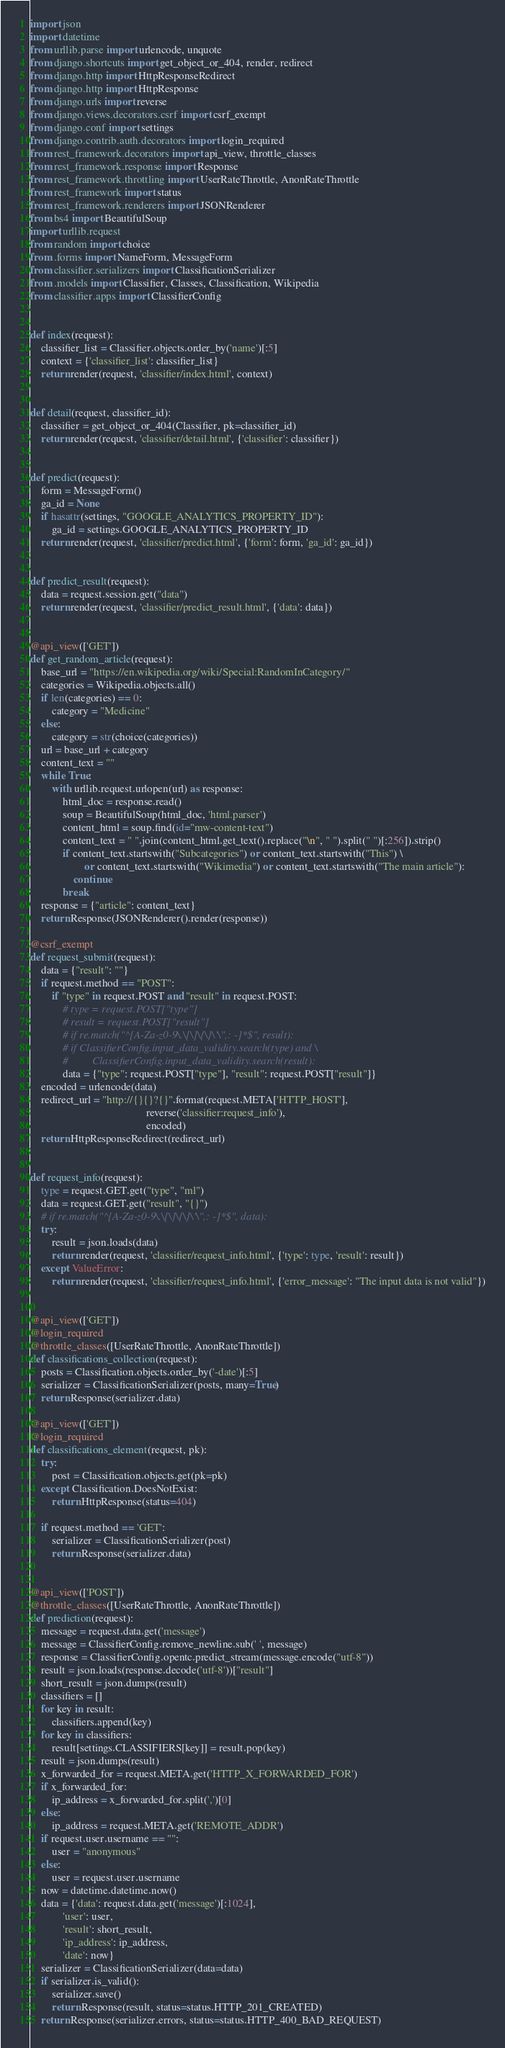Convert code to text. <code><loc_0><loc_0><loc_500><loc_500><_Python_>import json
import datetime
from urllib.parse import urlencode, unquote
from django.shortcuts import get_object_or_404, render, redirect
from django.http import HttpResponseRedirect
from django.http import HttpResponse
from django.urls import reverse
from django.views.decorators.csrf import csrf_exempt
from django.conf import settings
from django.contrib.auth.decorators import login_required
from rest_framework.decorators import api_view, throttle_classes
from rest_framework.response import Response
from rest_framework.throttling import UserRateThrottle, AnonRateThrottle
from rest_framework import status
from rest_framework.renderers import JSONRenderer
from bs4 import BeautifulSoup
import urllib.request
from random import choice
from .forms import NameForm, MessageForm
from classifier.serializers import ClassificationSerializer
from .models import Classifier, Classes, Classification, Wikipedia
from classifier.apps import ClassifierConfig


def index(request):
    classifier_list = Classifier.objects.order_by('name')[:5]
    context = {'classifier_list': classifier_list}
    return render(request, 'classifier/index.html', context)


def detail(request, classifier_id):
    classifier = get_object_or_404(Classifier, pk=classifier_id)
    return render(request, 'classifier/detail.html', {'classifier': classifier})


def predict(request):
    form = MessageForm()
    ga_id = None
    if hasattr(settings, "GOOGLE_ANALYTICS_PROPERTY_ID"):
        ga_id = settings.GOOGLE_ANALYTICS_PROPERTY_ID
    return render(request, 'classifier/predict.html', {'form': form, 'ga_id': ga_id})


def predict_result(request):
    data = request.session.get("data")
    return render(request, 'classifier/predict_result.html', {'data': data})


@api_view(['GET'])
def get_random_article(request):
    base_url = "https://en.wikipedia.org/wiki/Special:RandomInCategory/"
    categories = Wikipedia.objects.all()
    if len(categories) == 0:
        category = "Medicine"
    else:
        category = str(choice(categories))
    url = base_url + category
    content_text = ""
    while True:
        with urllib.request.urlopen(url) as response:
            html_doc = response.read()
            soup = BeautifulSoup(html_doc, 'html.parser')
            content_html = soup.find(id="mw-content-text")
            content_text = " ".join(content_html.get_text().replace("\n", " ").split(" ")[:256]).strip()
            if content_text.startswith("Subcategories") or content_text.startswith("This") \
                    or content_text.startswith("Wikimedia") or content_text.startswith("The main article"):
                continue
            break
    response = {"article": content_text}
    return Response(JSONRenderer().render(response))

@csrf_exempt
def request_submit(request):
    data = {"result": ""}
    if request.method == "POST":
        if "type" in request.POST and "result" in request.POST:
            # type = request.POST["type"]
            # result = request.POST["result"]
            # if re.match("^[A-Za-z0-9\.\[\]\{\}\'\",: -]*$", result):
            # if ClassifierConfig.input_data_validity.search(type) and \
            #         ClassifierConfig.input_data_validity.search(result):
            data = {"type": request.POST["type"], "result": request.POST["result"]}
    encoded = urlencode(data)
    redirect_url = "http://{}{}?{}".format(request.META['HTTP_HOST'],
                                           reverse('classifier:request_info'),
                                           encoded)
    return HttpResponseRedirect(redirect_url)


def request_info(request):
    type = request.GET.get("type", "ml")
    data = request.GET.get("result", "{}")
    # if re.match("^[A-Za-z0-9\.\[\]\{\}\'\",: -]*$", data):
    try:
        result = json.loads(data)
        return render(request, 'classifier/request_info.html', {'type': type, 'result': result})
    except ValueError:
        return render(request, 'classifier/request_info.html', {'error_message': "The input data is not valid"})


@api_view(['GET'])
@login_required
@throttle_classes([UserRateThrottle, AnonRateThrottle])
def classifications_collection(request):
    posts = Classification.objects.order_by('-date')[:5]
    serializer = ClassificationSerializer(posts, many=True)
    return Response(serializer.data)

@api_view(['GET'])
@login_required
def classifications_element(request, pk):
    try:
        post = Classification.objects.get(pk=pk)
    except Classification.DoesNotExist:
        return HttpResponse(status=404)

    if request.method == 'GET':
        serializer = ClassificationSerializer(post)
        return Response(serializer.data)


@api_view(['POST'])
@throttle_classes([UserRateThrottle, AnonRateThrottle])
def prediction(request):
    message = request.data.get('message')
    message = ClassifierConfig.remove_newline.sub(' ', message)
    response = ClassifierConfig.opentc.predict_stream(message.encode("utf-8"))
    result = json.loads(response.decode('utf-8'))["result"]
    short_result = json.dumps(result)
    classifiers = []
    for key in result:
        classifiers.append(key)
    for key in classifiers:
        result[settings.CLASSIFIERS[key]] = result.pop(key)
    result = json.dumps(result)
    x_forwarded_for = request.META.get('HTTP_X_FORWARDED_FOR')
    if x_forwarded_for:
        ip_address = x_forwarded_for.split(',')[0]
    else:
        ip_address = request.META.get('REMOTE_ADDR')
    if request.user.username == "":
        user = "anonymous"
    else:
        user = request.user.username
    now = datetime.datetime.now()
    data = {'data': request.data.get('message')[:1024],
            'user': user,
            'result': short_result,
            'ip_address': ip_address,
            'date': now}
    serializer = ClassificationSerializer(data=data)
    if serializer.is_valid():
        serializer.save()
        return Response(result, status=status.HTTP_201_CREATED)
    return Response(serializer.errors, status=status.HTTP_400_BAD_REQUEST)
</code> 